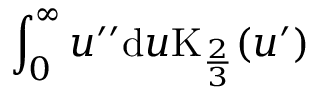Convert formula to latex. <formula><loc_0><loc_0><loc_500><loc_500>\int _ { 0 } ^ { \infty } u ^ { \prime \prime } d u K _ { \frac { 2 } { 3 } } ( u ^ { \prime } )</formula> 